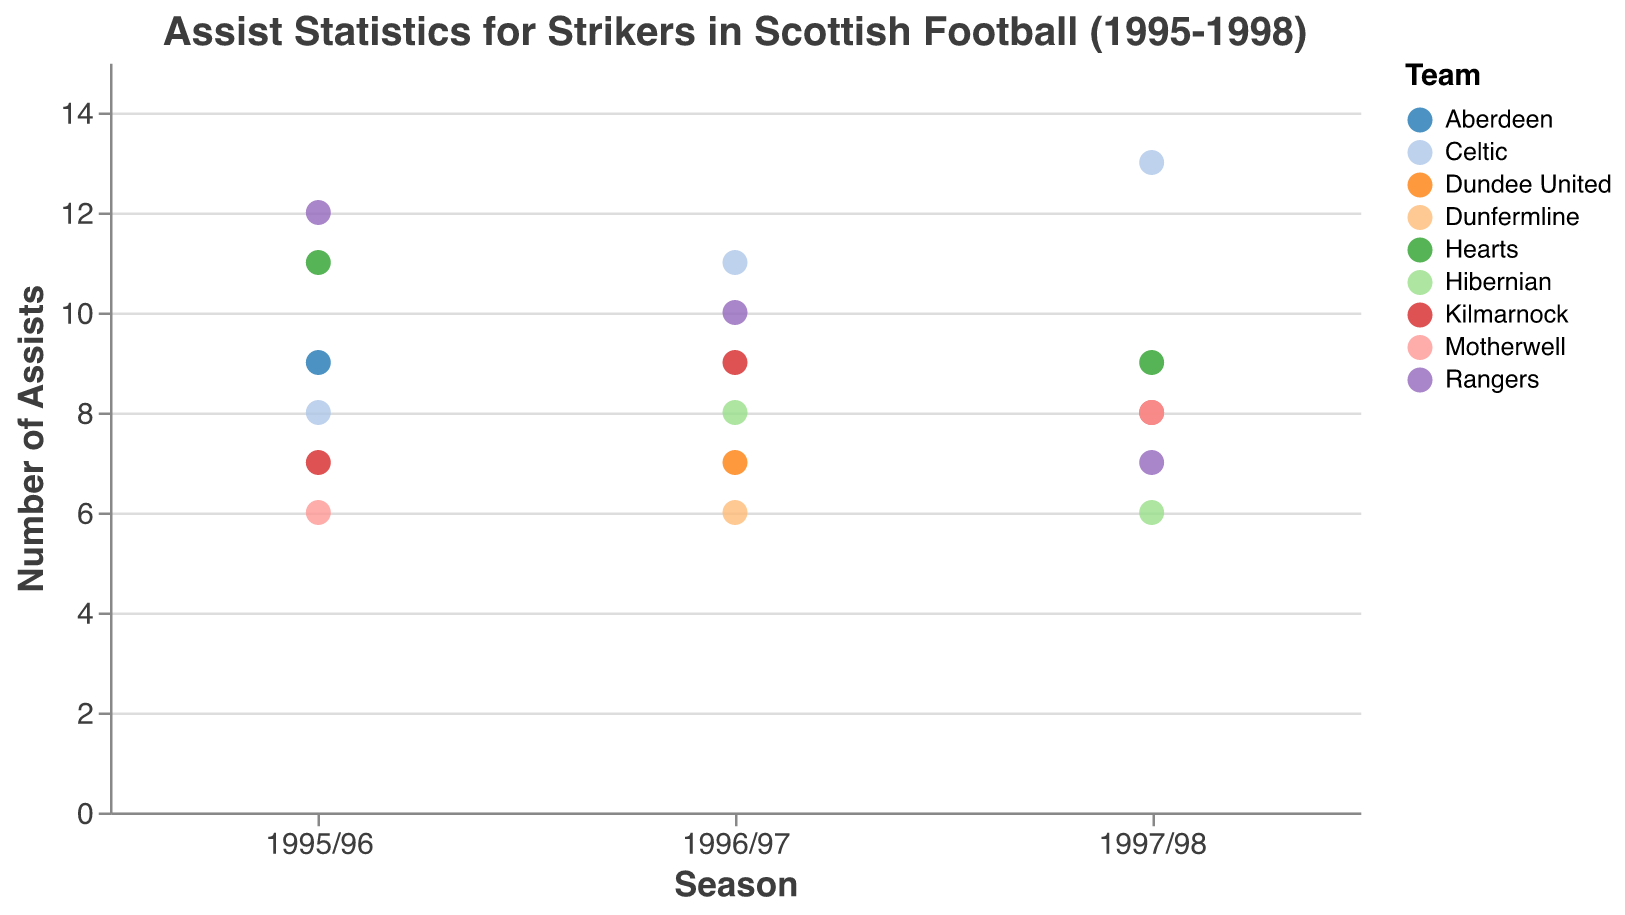Which team had the player with the highest number of assists in the 1997/98 season? The dot representing Henrik Larsson from Celtic in the 1997/98 season is at 13 on the y-axis, the highest value for that season.
Answer: Celtic How many assists did Scott Findlay make in the 1995/96 season? The dot for Scott Findlay in the 1995/96 season is located at 7 on the y-axis.
Answer: 7 What is the range of assists recorded by strikers in the 1996/97 season? The highest assist value in the 1996/97 season is 11 (Pierre van Hooijdonk) and the lowest is 6 (Derek Lilley), so the range is 11 - 6.
Answer: 5 Which season did Scott Findlay record his highest number of assists? By comparing the dots for Scott Findlay over the seasons, the highest value is 9, which occurs in the 1996/97 season.
Answer: 1996/97 Which player had the fewest assists in the 1997/98 season and how many? The dot for Stephane Adam (Hibernian) in the 1997/98 season is at the lowest point on the y-axis, corresponding to 6 assists.
Answer: Stephane Adam, 6 Compare the number of assists by strikers from Rangers in the 1995/96 season and 1996/97 season. Ally McCoist from Rangers recorded 12 assists in 1995/96 and 10 in 1996/97, so the comparison is 12 > 10.
Answer: 12, 10 What's the average number of assists for Scott Findlay over the three seasons? Scott Findlay's assists are 7, 9, and 8 over the three seasons. The sum is 24 and the average is 24 / 3.
Answer: 8 Which team appears the most in the plot across all seasons? Rangers have three players with assists values (Ally McCoist and Marco Negri) across the three seasons, which is their highest appearance.
Answer: Rangers 